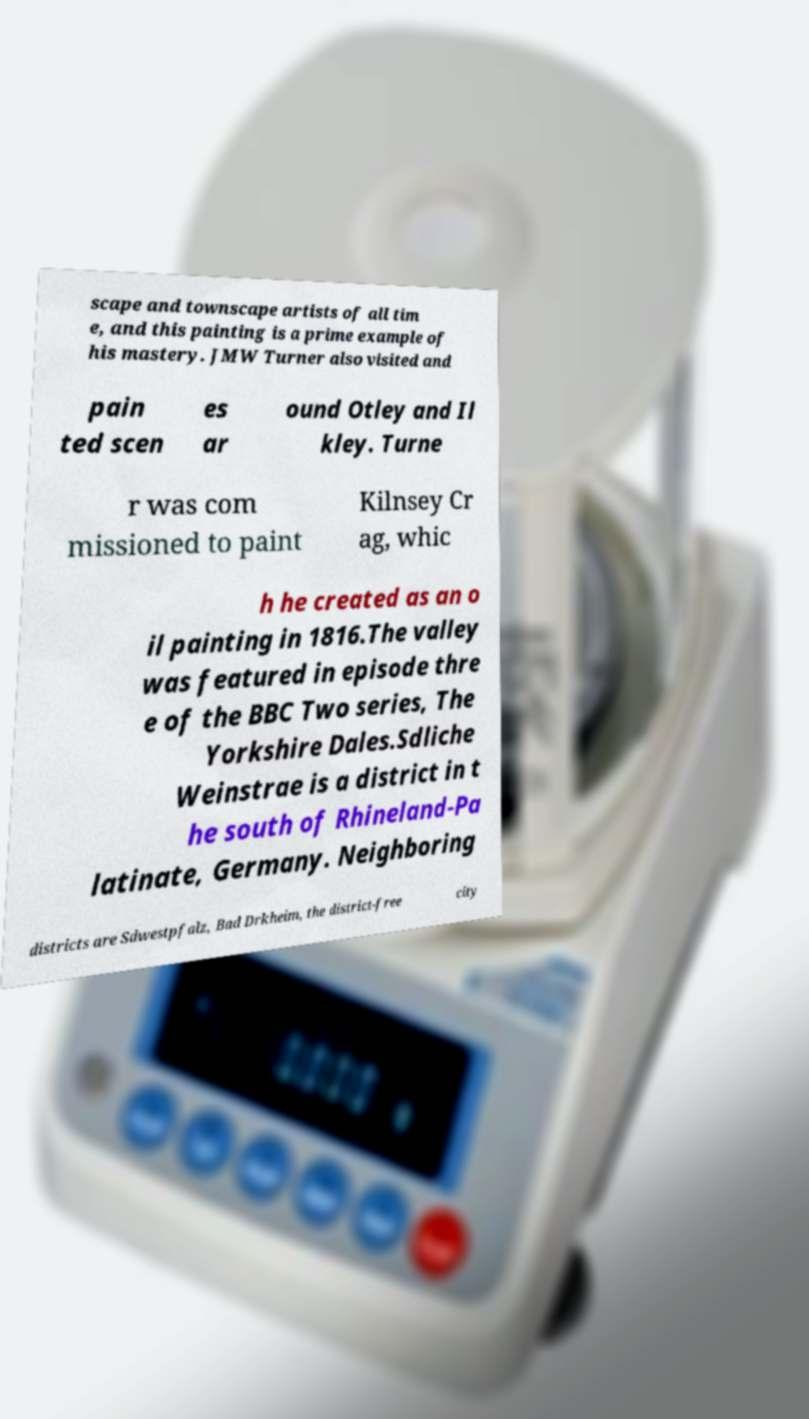Could you extract and type out the text from this image? scape and townscape artists of all tim e, and this painting is a prime example of his mastery. JMW Turner also visited and pain ted scen es ar ound Otley and Il kley. Turne r was com missioned to paint Kilnsey Cr ag, whic h he created as an o il painting in 1816.The valley was featured in episode thre e of the BBC Two series, The Yorkshire Dales.Sdliche Weinstrae is a district in t he south of Rhineland-Pa latinate, Germany. Neighboring districts are Sdwestpfalz, Bad Drkheim, the district-free city 